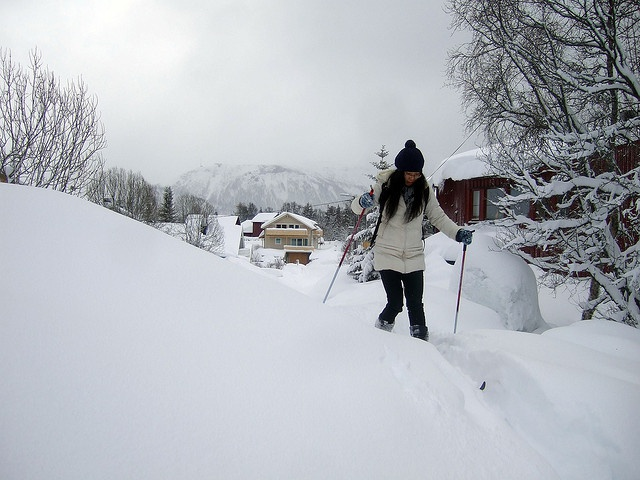Describe the objects in this image and their specific colors. I can see people in lightgray, black, darkgray, and gray tones, skis in lightgray, black, gray, and darkgray tones, and skis in lightgray, navy, gray, black, and darkgray tones in this image. 